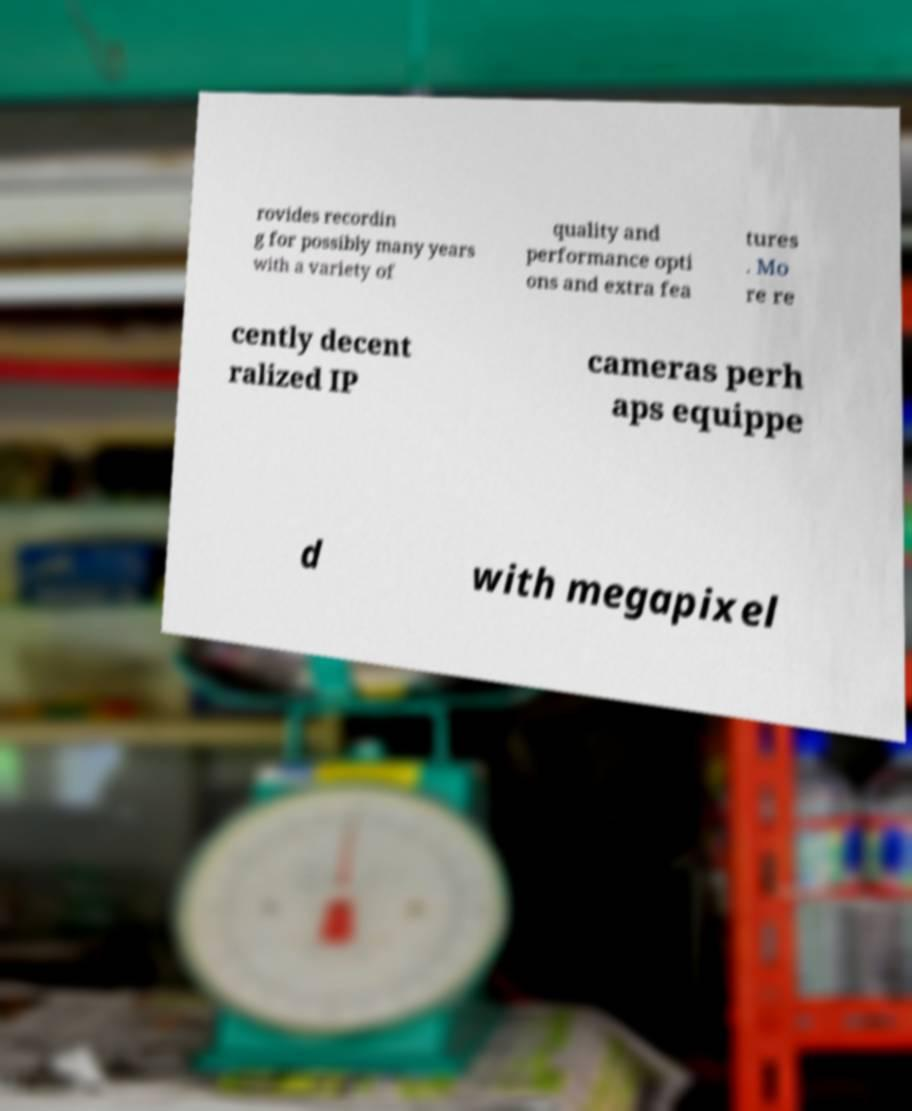Please read and relay the text visible in this image. What does it say? rovides recordin g for possibly many years with a variety of quality and performance opti ons and extra fea tures . Mo re re cently decent ralized IP cameras perh aps equippe d with megapixel 